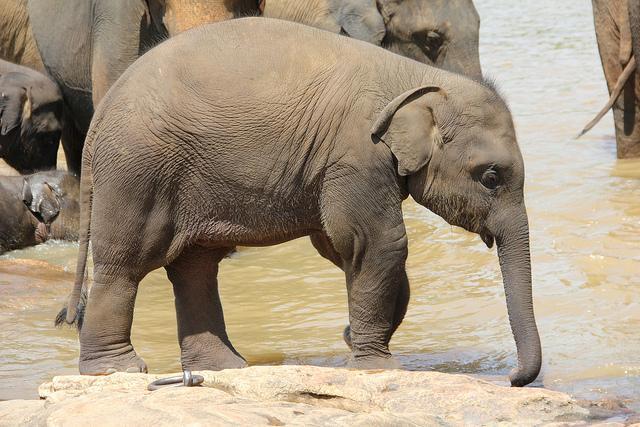How many elephants are in the picture?
Give a very brief answer. 7. How many people have on glasses?
Give a very brief answer. 0. 